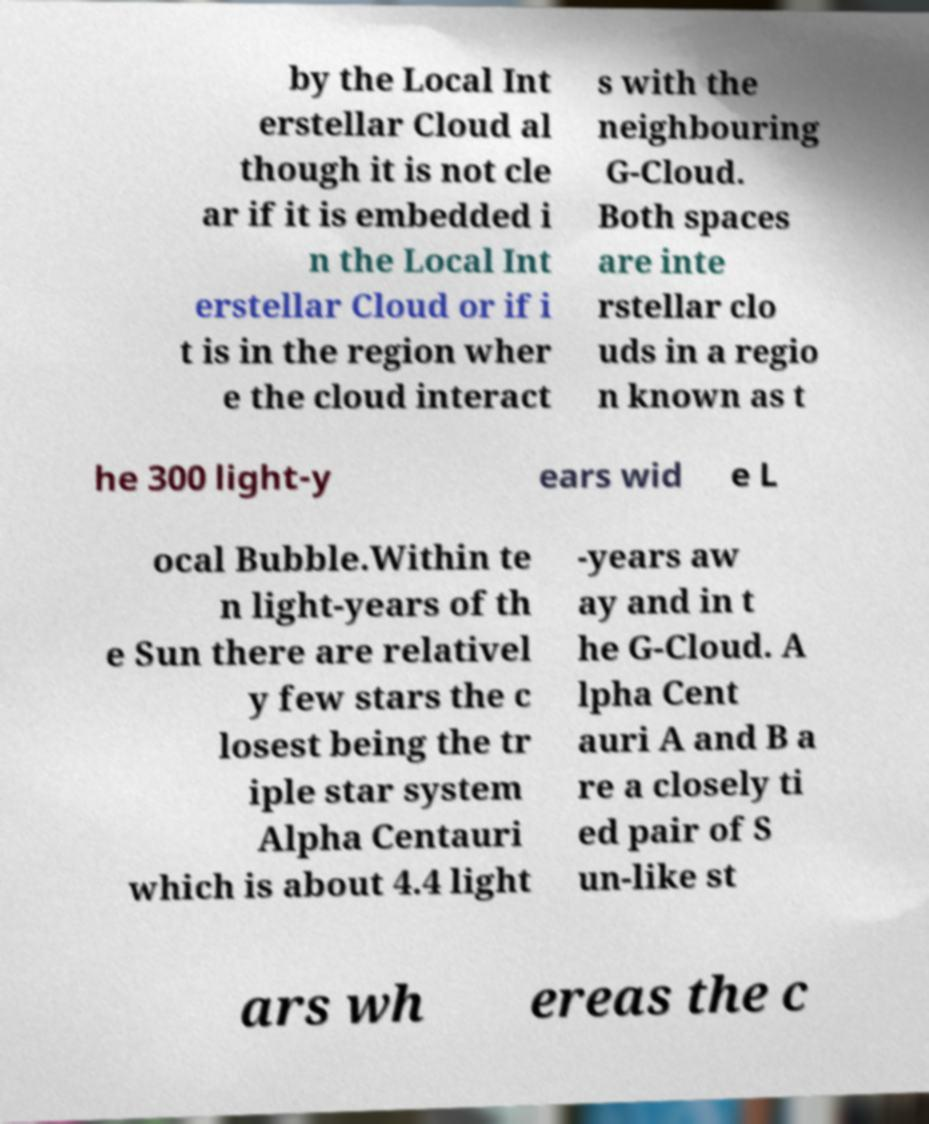Can you accurately transcribe the text from the provided image for me? by the Local Int erstellar Cloud al though it is not cle ar if it is embedded i n the Local Int erstellar Cloud or if i t is in the region wher e the cloud interact s with the neighbouring G-Cloud. Both spaces are inte rstellar clo uds in a regio n known as t he 300 light-y ears wid e L ocal Bubble.Within te n light-years of th e Sun there are relativel y few stars the c losest being the tr iple star system Alpha Centauri which is about 4.4 light -years aw ay and in t he G-Cloud. A lpha Cent auri A and B a re a closely ti ed pair of S un-like st ars wh ereas the c 